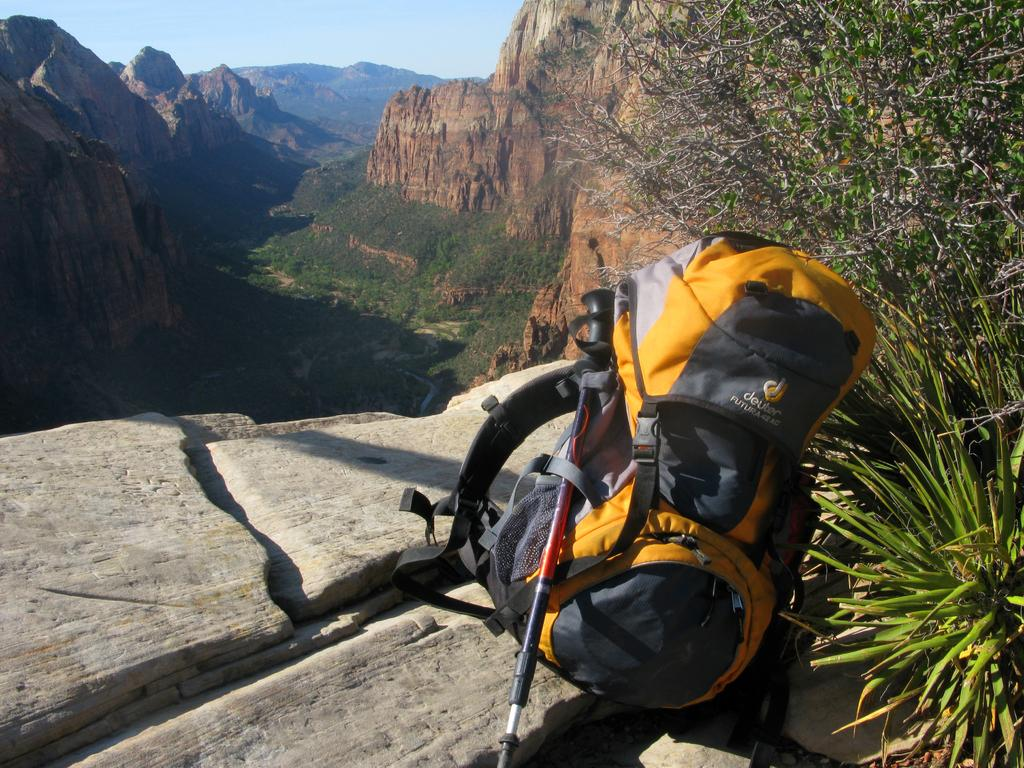What object can be seen in the image that is commonly used for carrying items? There is a backpack in the image. What other object is present in the image that is not typically used for carrying items? There is a stick in the image. Where are the backpack and stick placed in the image? The backpack and stick are placed on a stone. What type of vegetation can be seen in the image? There is a plant in the image. What can be seen in the background of the image that suggests a particular type of landscape? There is a deep valley in the background of the image. What type of flesh can be seen on the stick in the image? There is no flesh present on the stick in the image. What brand of toothpaste is advertised on the backpack in the image? There is no toothpaste or advertisement present on the backpack in the image. 